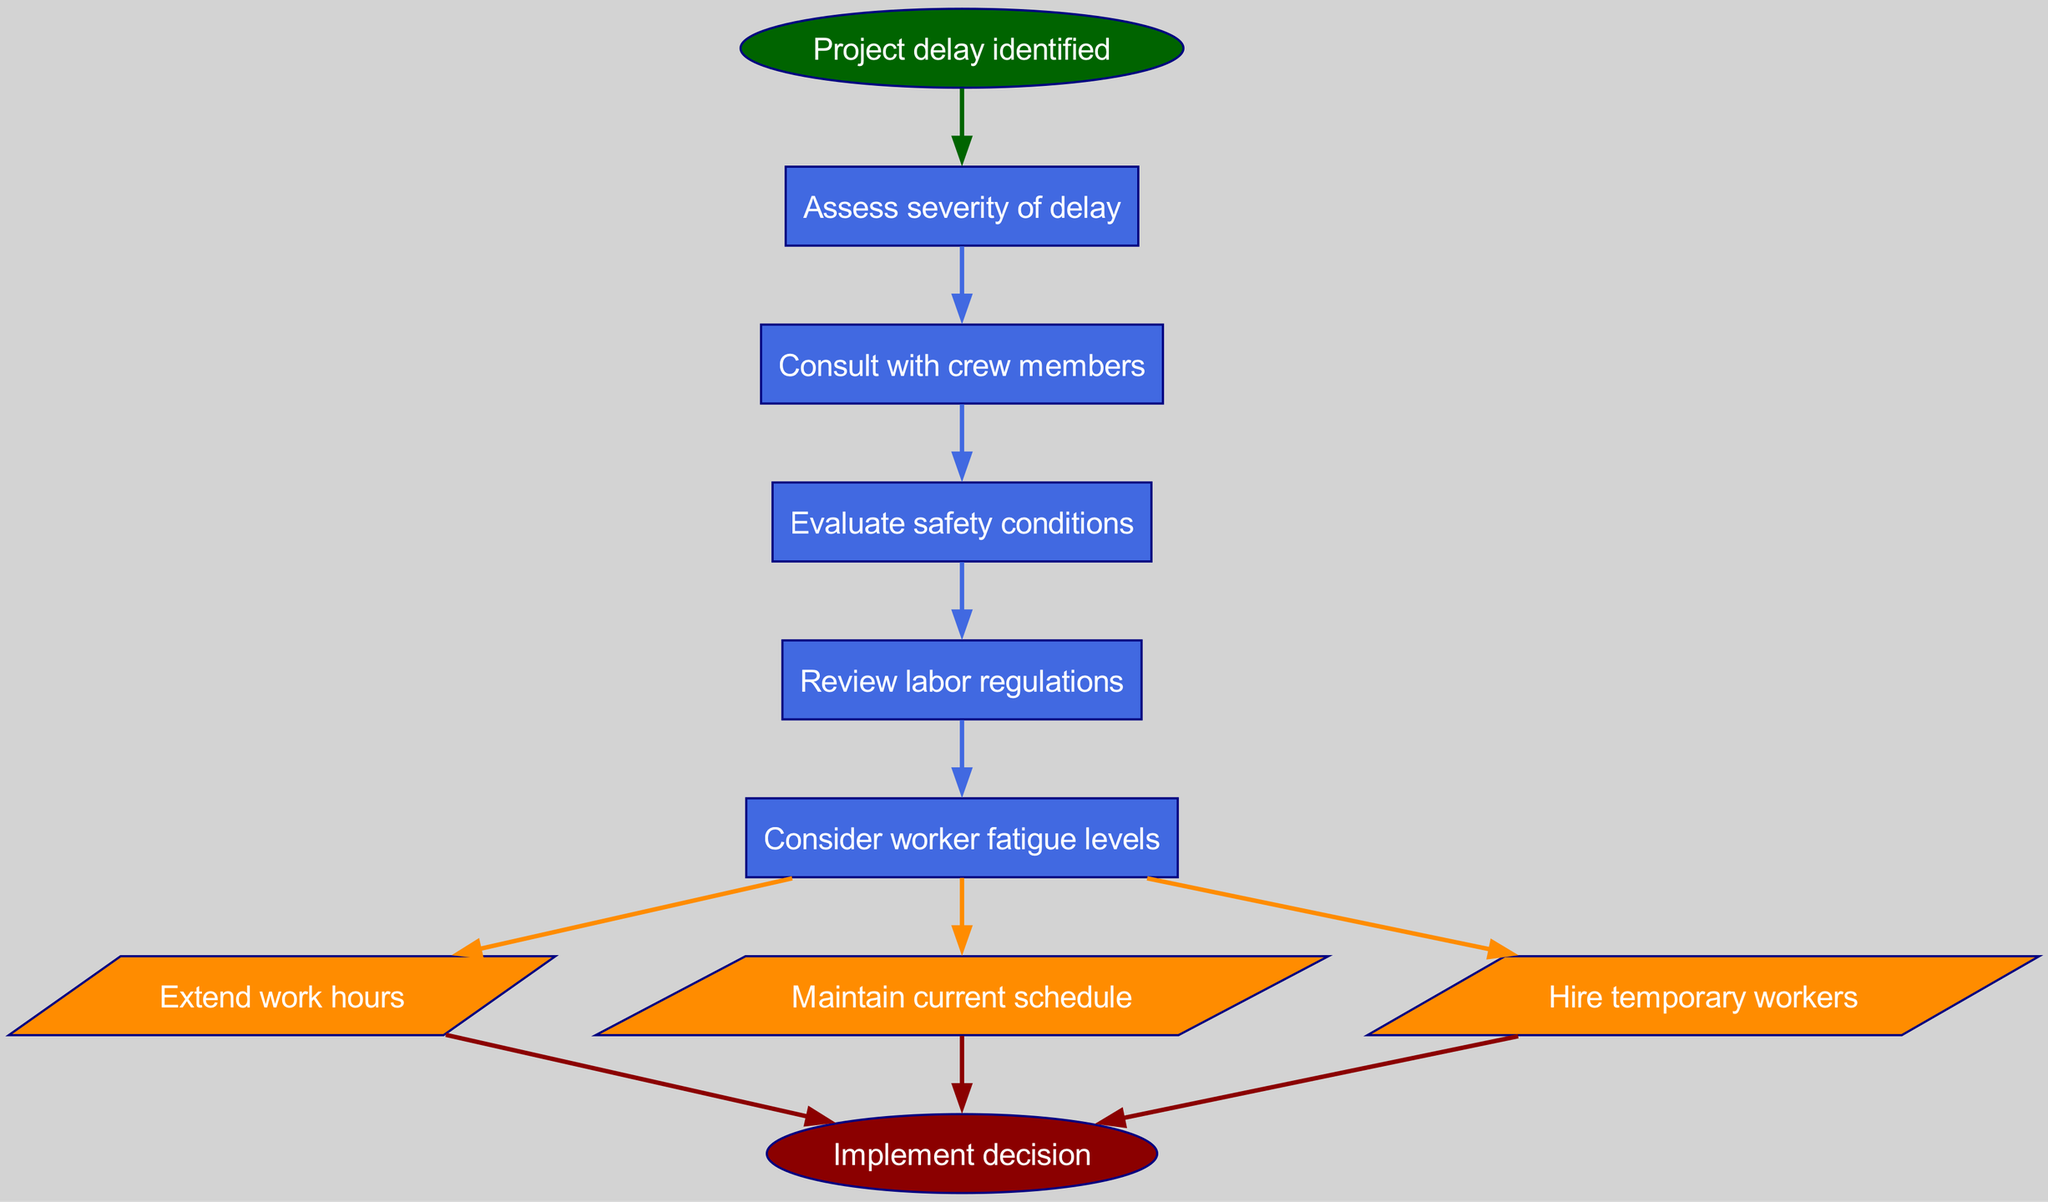What is the starting point of the flow diagram? The flow diagram begins with the node labeled "Project delay identified," which indicates the initiating event for the decision-making process.
Answer: Project delay identified How many decision nodes are there in the diagram? There are five decision nodes, each representing a key consideration in the decision-making process related to project delays.
Answer: 5 What will happen if worker fatigue levels are a concern? If worker fatigue levels are considered too high, it may affect the decision; thus, one of the actions could involve hiring temporary workers to alleviate the workload.
Answer: Hire temporary workers What is the color of the action nodes? The action nodes are colored dark orange, which distinguishes them from the decision nodes and indicates a distinct category of outcomes in the flow.
Answer: Dark orange What is the last action before implementing the decision? The last action before moving to the final stage of "Implement decision" involves one of the decisions made based on assessing the situation, which can include extending work hours, maintaining schedule, or hiring temporary workers.
Answer: Extend work hours (or Maintain current schedule, or Hire temporary workers) If safety conditions are evaluated as poor, what will likely happen next? If safety conditions are found to be inadequate, it would suggest that extending work hours may not be the best option, leading possibly to maintaining the current schedule or seeking other solutions aligned with safety.
Answer: Maintain current schedule Which node would follow "Assess severity of delay" if the decision leads to extending work hours? After assessing the severity of the delay, if the outcome is to extend work hours, the next step would typically involve evaluating safety conditions to ensure that this action does not compromise worker safety.
Answer: Check safety conditions What is the final node in the flow chart? The flow chart concludes with the implementation stage, denoted as "Implement decision," which is the action step after going through all previous assessments and decisions.
Answer: Implement decision 